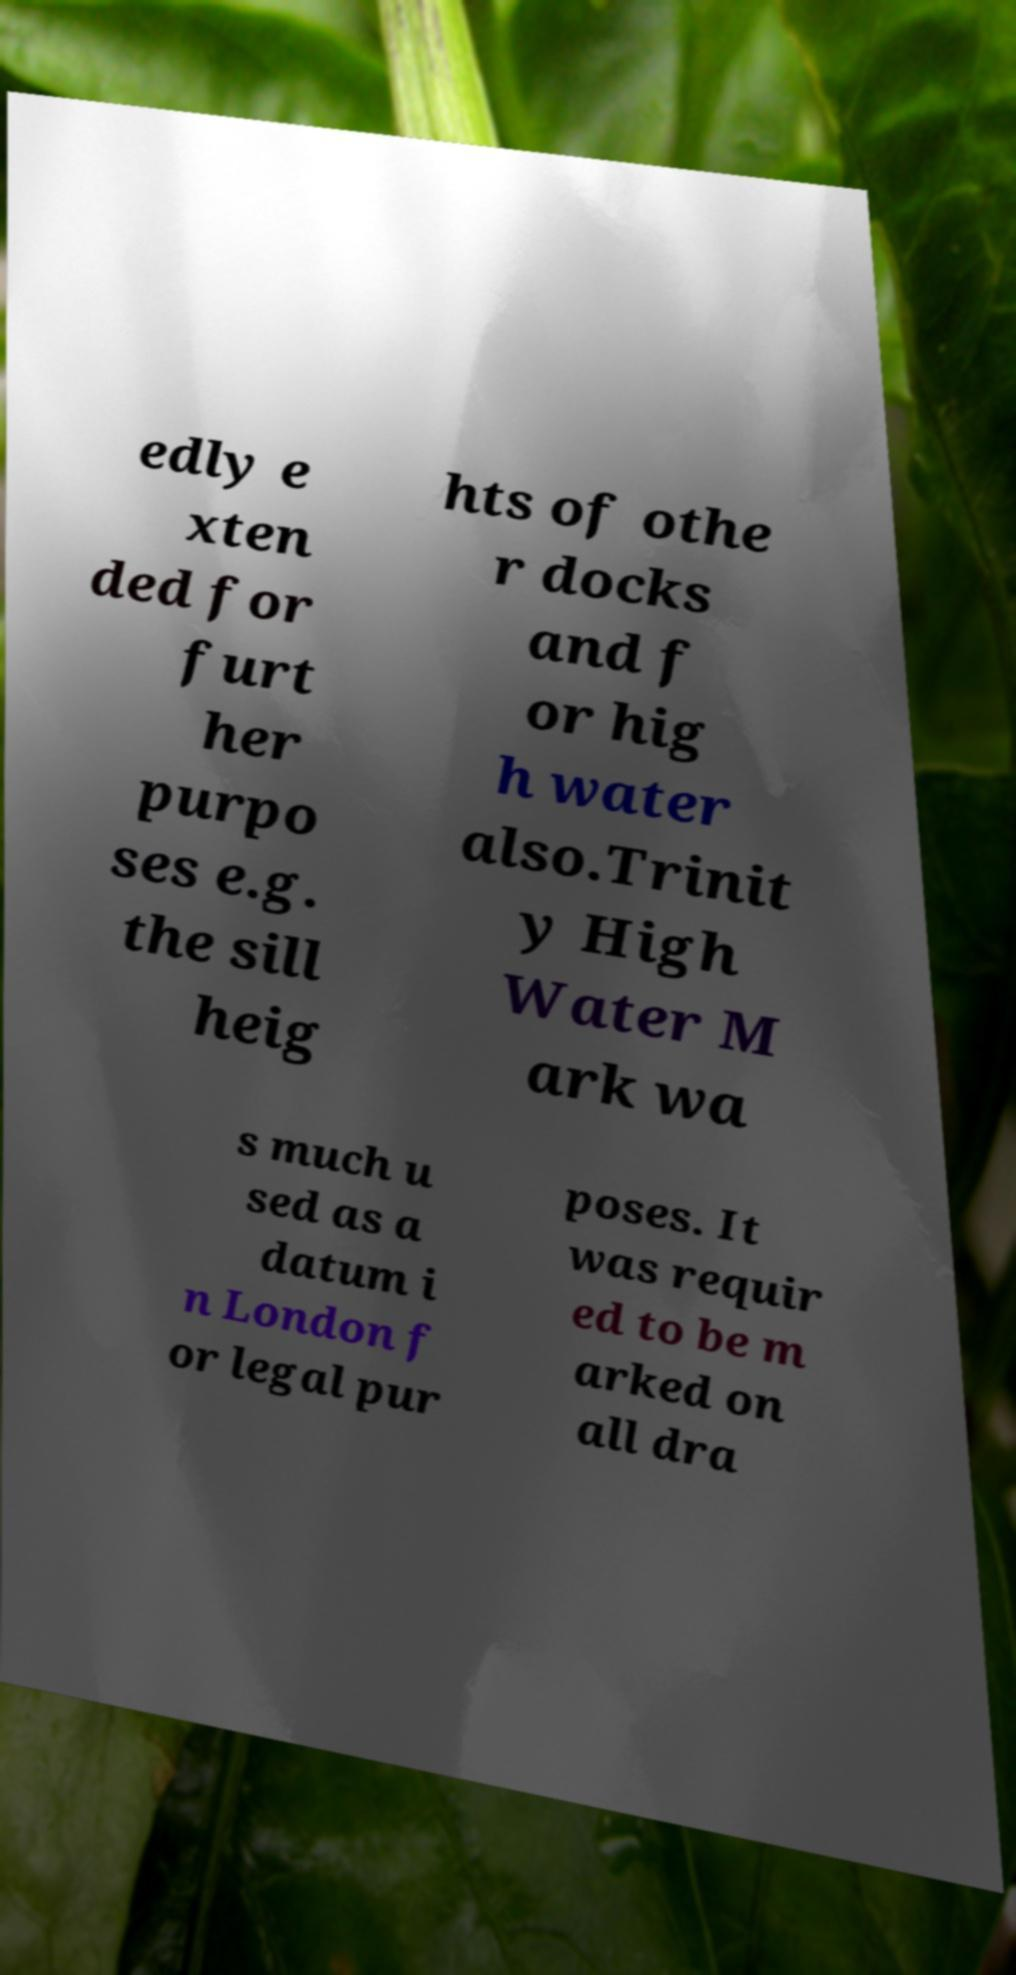Could you extract and type out the text from this image? edly e xten ded for furt her purpo ses e.g. the sill heig hts of othe r docks and f or hig h water also.Trinit y High Water M ark wa s much u sed as a datum i n London f or legal pur poses. It was requir ed to be m arked on all dra 